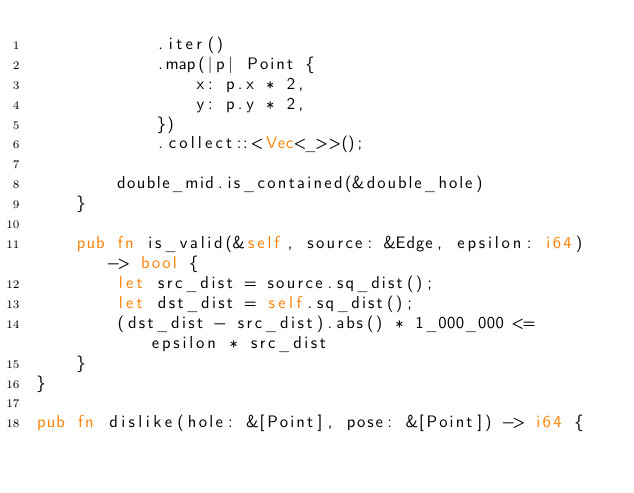Convert code to text. <code><loc_0><loc_0><loc_500><loc_500><_Rust_>            .iter()
            .map(|p| Point {
                x: p.x * 2,
                y: p.y * 2,
            })
            .collect::<Vec<_>>();

        double_mid.is_contained(&double_hole)
    }

    pub fn is_valid(&self, source: &Edge, epsilon: i64) -> bool {
        let src_dist = source.sq_dist();
        let dst_dist = self.sq_dist();
        (dst_dist - src_dist).abs() * 1_000_000 <= epsilon * src_dist
    }
}

pub fn dislike(hole: &[Point], pose: &[Point]) -> i64 {</code> 